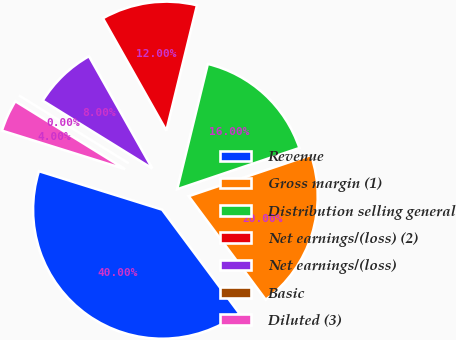Convert chart to OTSL. <chart><loc_0><loc_0><loc_500><loc_500><pie_chart><fcel>Revenue<fcel>Gross margin (1)<fcel>Distribution selling general<fcel>Net earnings/(loss) (2)<fcel>Net earnings/(loss)<fcel>Basic<fcel>Diluted (3)<nl><fcel>40.0%<fcel>20.0%<fcel>16.0%<fcel>12.0%<fcel>8.0%<fcel>0.0%<fcel>4.0%<nl></chart> 